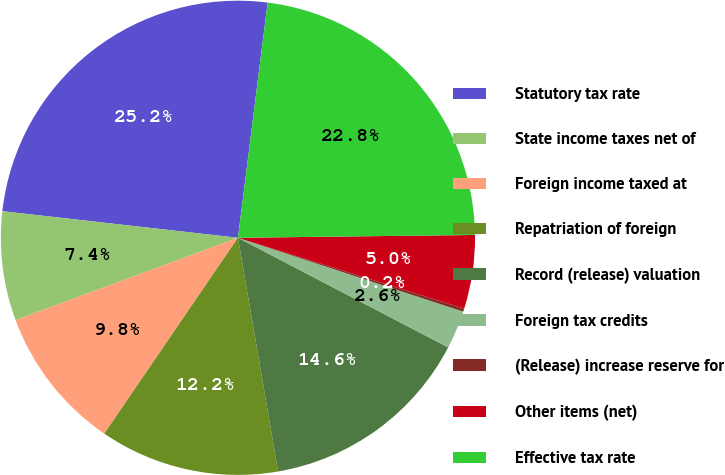Convert chart. <chart><loc_0><loc_0><loc_500><loc_500><pie_chart><fcel>Statutory tax rate<fcel>State income taxes net of<fcel>Foreign income taxed at<fcel>Repatriation of foreign<fcel>Record (release) valuation<fcel>Foreign tax credits<fcel>(Release) increase reserve for<fcel>Other items (net)<fcel>Effective tax rate<nl><fcel>25.21%<fcel>7.43%<fcel>9.83%<fcel>12.24%<fcel>14.64%<fcel>2.61%<fcel>0.21%<fcel>5.02%<fcel>22.81%<nl></chart> 